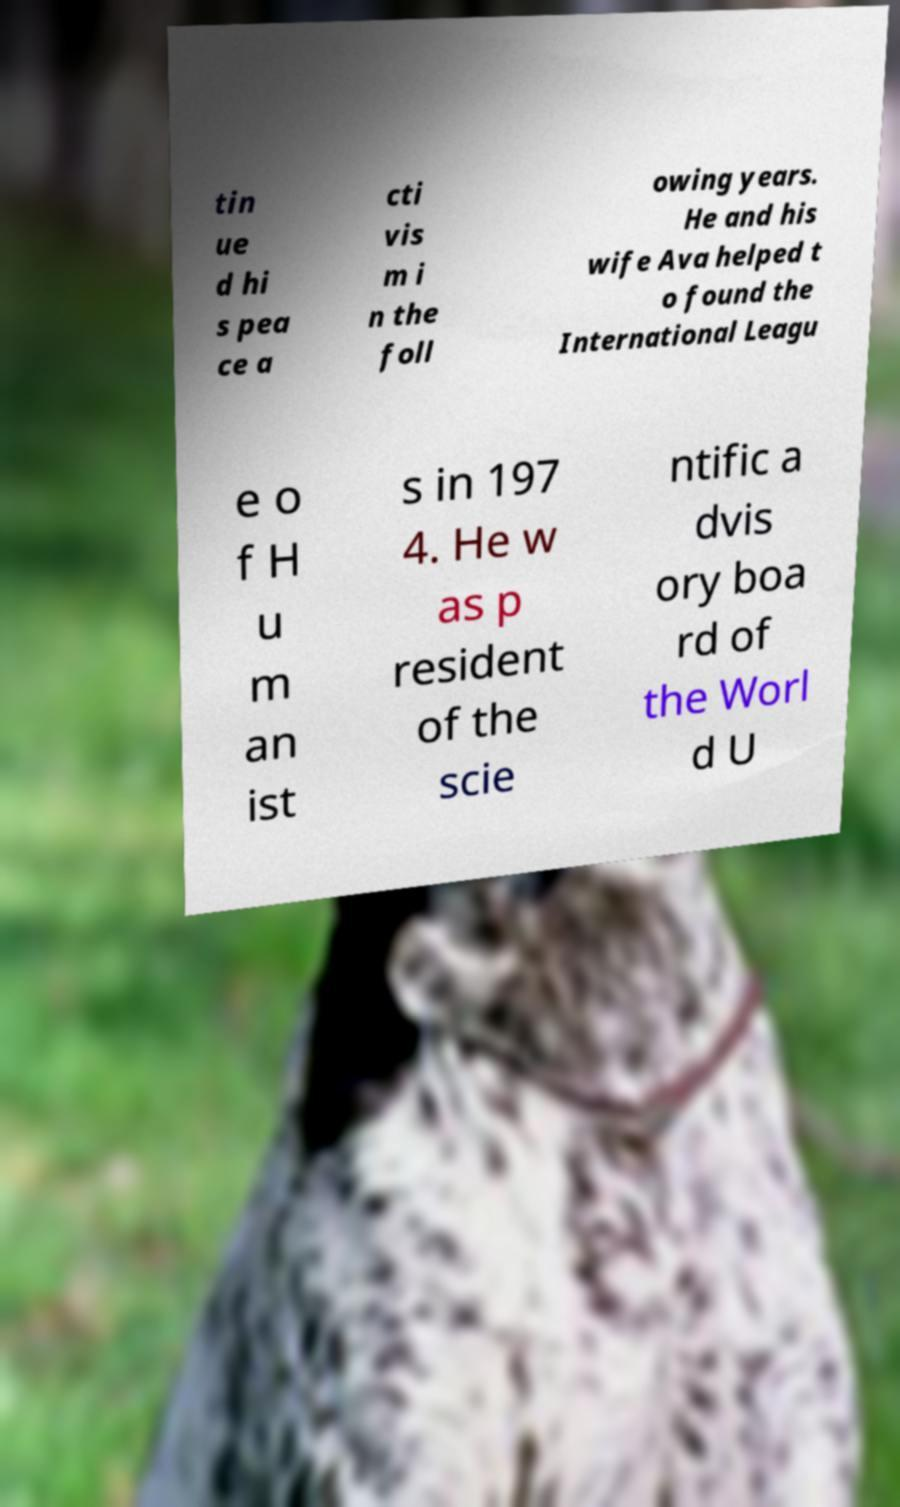Could you extract and type out the text from this image? tin ue d hi s pea ce a cti vis m i n the foll owing years. He and his wife Ava helped t o found the International Leagu e o f H u m an ist s in 197 4. He w as p resident of the scie ntific a dvis ory boa rd of the Worl d U 